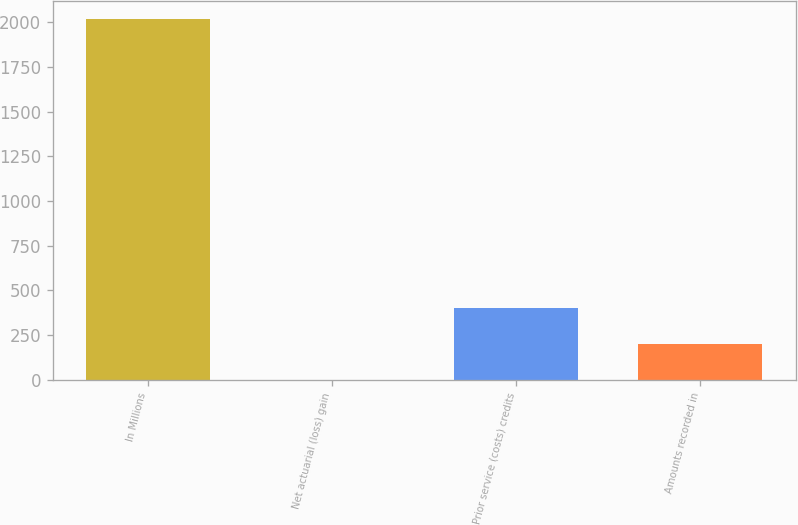Convert chart. <chart><loc_0><loc_0><loc_500><loc_500><bar_chart><fcel>In Millions<fcel>Net actuarial (loss) gain<fcel>Prior service (costs) credits<fcel>Amounts recorded in<nl><fcel>2019<fcel>0.1<fcel>403.88<fcel>201.99<nl></chart> 